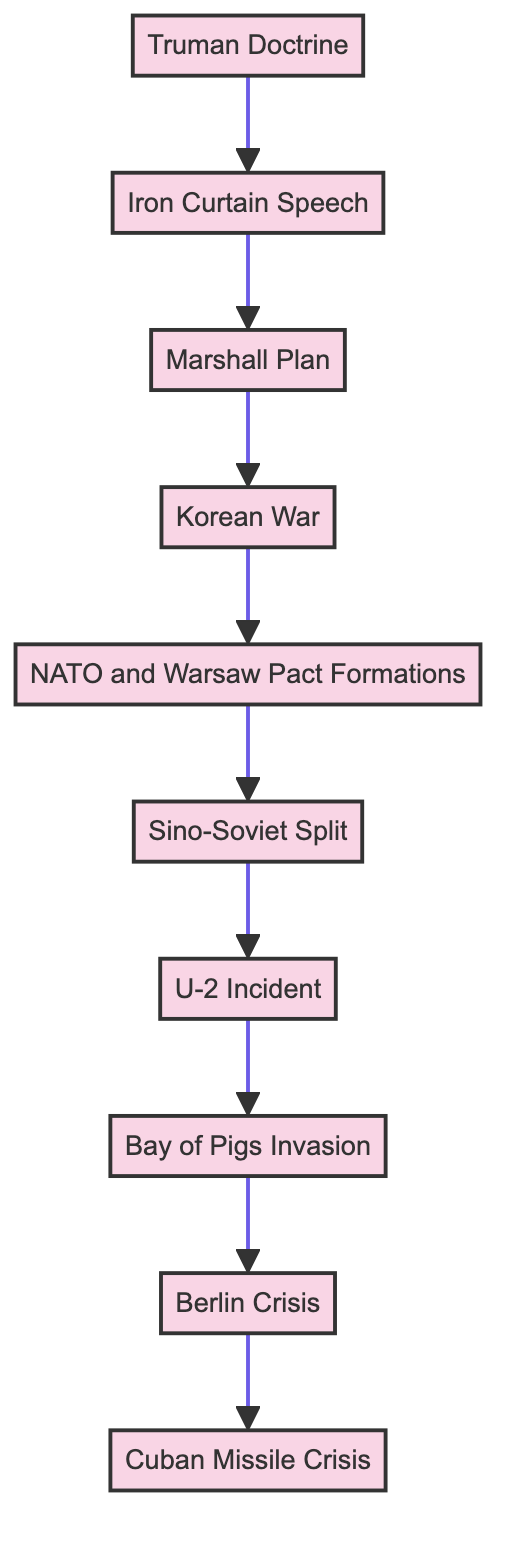What is the last event in the flow? The flow chart shows a series of events leading upward, and the last event listed at the top is the Cuban Missile Crisis.
Answer: Cuban Missile Crisis How many events are in the flowchart? By counting the elements starting from the Truman Doctrine to the Cuban Missile Crisis, there are a total of 10 events listed in the flow chart.
Answer: 10 What event directly precedes the Berlin Crisis? In the flow chart, the event that directly precedes the Berlin Crisis is the Bay of Pigs Invasion, as indicated by the connecting arrows.
Answer: Bay of Pigs Invasion Which event is a direct consequence of the U-2 Incident? The flow chart indicates that the Bay of Pigs Invasion is the event that follows directly after the U-2 Incident, suggesting a consequential relationship.
Answer: Bay of Pigs Invasion Which two events are linked by the Korean War? The flow chart shows that the Korean War leads to the formation of NATO and the Warsaw Pact, indicating a connection between those two events.
Answer: NATO and Warsaw Pact Formations What event initiates the chain of escalation in the Cold War? The flow chart indicates that the Truman Doctrine serves as the starting point for the escalation of events that follow, thus initiating the chain of escalation.
Answer: Truman Doctrine How are the Soviet Union's perceptions shaped in the context of Western initiatives? The diagram suggests that the initiation of the Marshall Plan, following the Iron Curtain Speech, is perceived by the Soviet Union as a direct threat to its influence.
Answer: Marshall Plan What is the relationship between the Korean War and NATO? The flow chart shows that the Korean War is a precursor event leading directly to the formation of NATO and Warsaw Pact, illustrating their relationship in the timeline of Cold War events.
Answer: NATO and Warsaw Pact Formations Which two events together reflect the Sino-Soviet dynamics? The flow chart connects the Sino-Soviet Split directly to the events leading up to the U-2 Incident, indicating that these two are closely related in reflecting the Sino-Soviet dynamics during the Cold War.
Answer: Sino-Soviet Split and U-2 Incident 